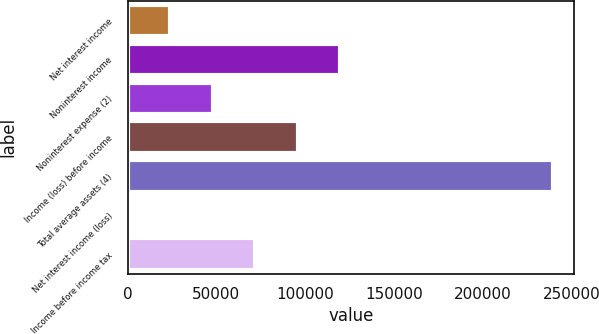Convert chart. <chart><loc_0><loc_0><loc_500><loc_500><bar_chart><fcel>Net interest income<fcel>Noninterest income<fcel>Noninterest expense (2)<fcel>Income (loss) before income<fcel>Total average assets (4)<fcel>Net interest income (loss)<fcel>Income before income tax<nl><fcel>23942.5<fcel>119672<fcel>47875<fcel>95740<fcel>239335<fcel>10<fcel>71807.5<nl></chart> 